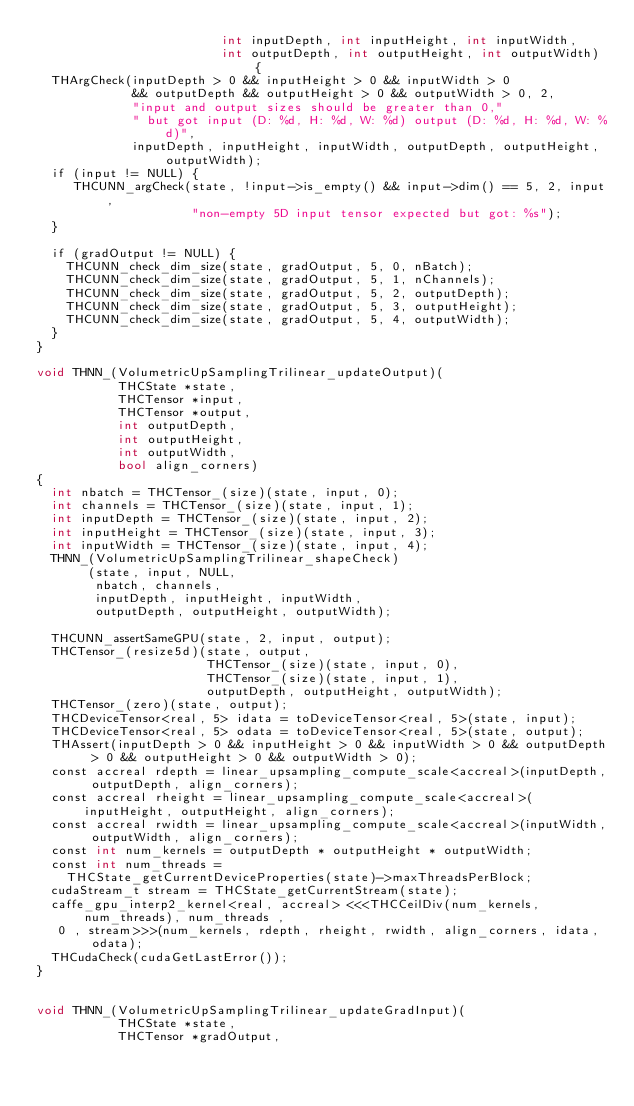<code> <loc_0><loc_0><loc_500><loc_500><_Cuda_>                         int inputDepth, int inputHeight, int inputWidth,
                         int outputDepth, int outputHeight, int outputWidth) {
  THArgCheck(inputDepth > 0 && inputHeight > 0 && inputWidth > 0
             && outputDepth && outputHeight > 0 && outputWidth > 0, 2,
             "input and output sizes should be greater than 0,"
             " but got input (D: %d, H: %d, W: %d) output (D: %d, H: %d, W: %d)",
             inputDepth, inputHeight, inputWidth, outputDepth, outputHeight, outputWidth);
  if (input != NULL) {
     THCUNN_argCheck(state, !input->is_empty() && input->dim() == 5, 2, input,
                     "non-empty 5D input tensor expected but got: %s");
  }

  if (gradOutput != NULL) {
    THCUNN_check_dim_size(state, gradOutput, 5, 0, nBatch);
    THCUNN_check_dim_size(state, gradOutput, 5, 1, nChannels);
    THCUNN_check_dim_size(state, gradOutput, 5, 2, outputDepth);
    THCUNN_check_dim_size(state, gradOutput, 5, 3, outputHeight);
    THCUNN_check_dim_size(state, gradOutput, 5, 4, outputWidth);
  }
}

void THNN_(VolumetricUpSamplingTrilinear_updateOutput)(
           THCState *state,
           THCTensor *input,
           THCTensor *output,
           int outputDepth,
           int outputHeight,
           int outputWidth,
           bool align_corners)
{
  int nbatch = THCTensor_(size)(state, input, 0);
  int channels = THCTensor_(size)(state, input, 1);
  int inputDepth = THCTensor_(size)(state, input, 2);
  int inputHeight = THCTensor_(size)(state, input, 3);
  int inputWidth = THCTensor_(size)(state, input, 4);
  THNN_(VolumetricUpSamplingTrilinear_shapeCheck)
       (state, input, NULL,
        nbatch, channels,
        inputDepth, inputHeight, inputWidth,
        outputDepth, outputHeight, outputWidth);

  THCUNN_assertSameGPU(state, 2, input, output);
  THCTensor_(resize5d)(state, output,
                       THCTensor_(size)(state, input, 0),
                       THCTensor_(size)(state, input, 1),
                       outputDepth, outputHeight, outputWidth);
  THCTensor_(zero)(state, output);
  THCDeviceTensor<real, 5> idata = toDeviceTensor<real, 5>(state, input);
  THCDeviceTensor<real, 5> odata = toDeviceTensor<real, 5>(state, output);
  THAssert(inputDepth > 0 && inputHeight > 0 && inputWidth > 0 && outputDepth > 0 && outputHeight > 0 && outputWidth > 0);
  const accreal rdepth = linear_upsampling_compute_scale<accreal>(inputDepth, outputDepth, align_corners);
  const accreal rheight = linear_upsampling_compute_scale<accreal>(inputHeight, outputHeight, align_corners);
  const accreal rwidth = linear_upsampling_compute_scale<accreal>(inputWidth, outputWidth, align_corners);
  const int num_kernels = outputDepth * outputHeight * outputWidth;
  const int num_threads =
    THCState_getCurrentDeviceProperties(state)->maxThreadsPerBlock;
  cudaStream_t stream = THCState_getCurrentStream(state);
  caffe_gpu_interp2_kernel<real, accreal> <<<THCCeilDiv(num_kernels, num_threads), num_threads ,
   0 , stream>>>(num_kernels, rdepth, rheight, rwidth, align_corners, idata, odata);
  THCudaCheck(cudaGetLastError());
}


void THNN_(VolumetricUpSamplingTrilinear_updateGradInput)(
           THCState *state,
           THCTensor *gradOutput,</code> 